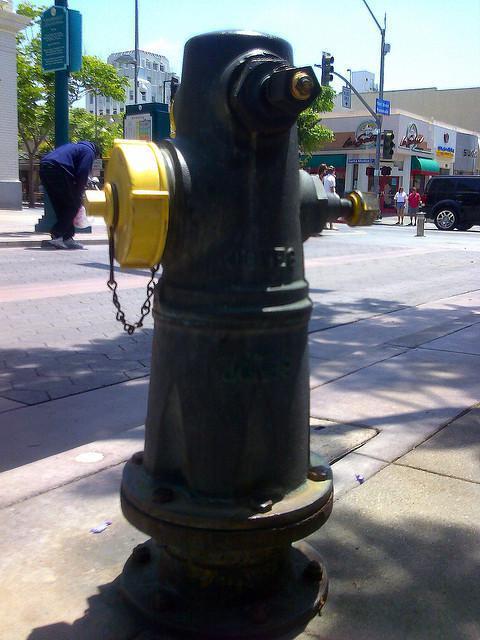Is the given caption "The fire hydrant is far away from the truck." fitting for the image?
Answer yes or no. Yes. 